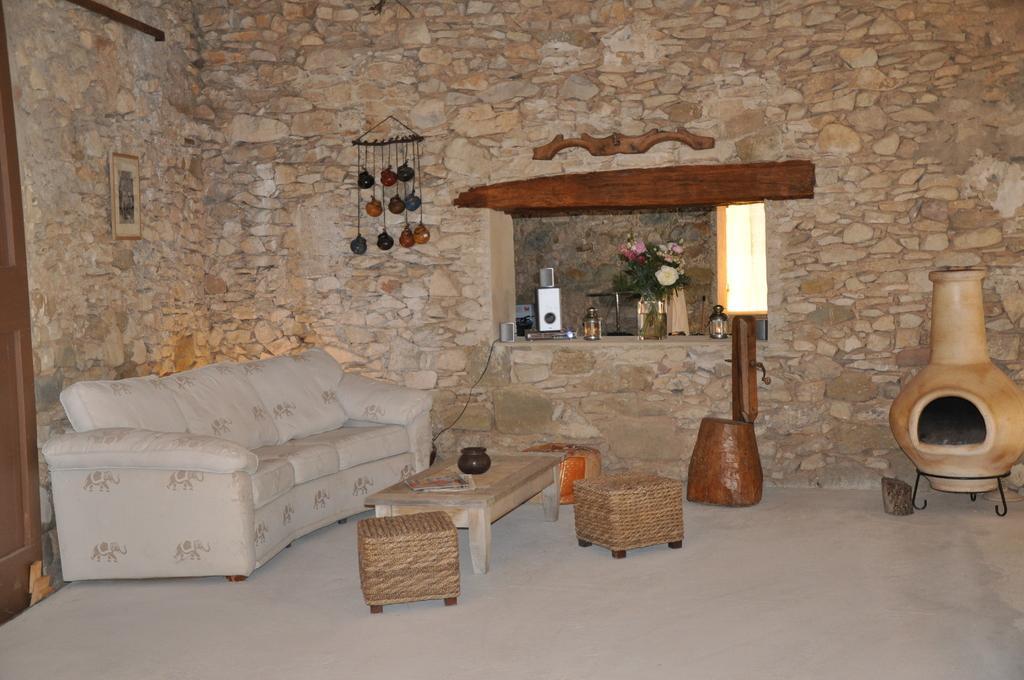Describe this image in one or two sentences. In this image i can see a couch, a table, two chairs at the back ground i can see a wall, a flower pot, a table. 